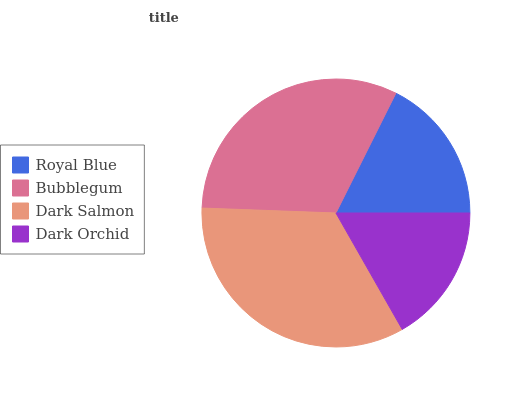Is Dark Orchid the minimum?
Answer yes or no. Yes. Is Dark Salmon the maximum?
Answer yes or no. Yes. Is Bubblegum the minimum?
Answer yes or no. No. Is Bubblegum the maximum?
Answer yes or no. No. Is Bubblegum greater than Royal Blue?
Answer yes or no. Yes. Is Royal Blue less than Bubblegum?
Answer yes or no. Yes. Is Royal Blue greater than Bubblegum?
Answer yes or no. No. Is Bubblegum less than Royal Blue?
Answer yes or no. No. Is Bubblegum the high median?
Answer yes or no. Yes. Is Royal Blue the low median?
Answer yes or no. Yes. Is Dark Orchid the high median?
Answer yes or no. No. Is Dark Orchid the low median?
Answer yes or no. No. 